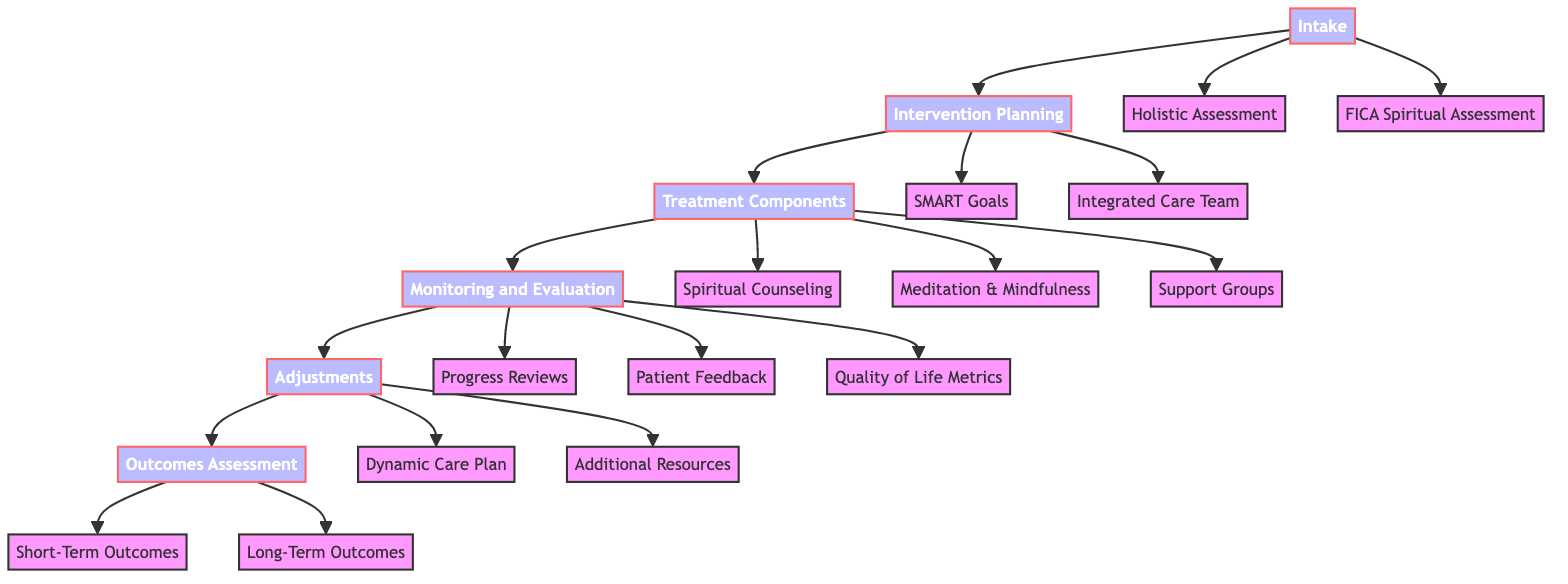What is the first step in the clinical pathway? The first step shown in the diagram is "Intake," indicating that this is the starting point of the clinical pathway.
Answer: Intake How many members are in the integrated care team? The diagram lists four members: Primary Physician, Oncology Specialist, Certified Spiritual Counselor, and Clinical Psychologist. Counting these, we find there are four members in total.
Answer: 4 What type of assessment tool is used for spiritual history? The diagram specifies the "FICA Spiritual Assessment Tool" as the assessment used for spiritual history.
Answer: FICA Spiritual Assessment Tool What is the frequency of spiritual counseling sessions? According to the diagram, spiritual counseling sessions are conducted weekly, as indicated in the "treatment components" section.
Answer: Weekly How often are progress reviews conducted by the healthcare team? The diagram states that progress reviews are done bi-monthly, which means every two months.
Answer: Bi-monthly What is the primary focus of the spiritual counseling sessions? The focus of the spiritual counseling sessions is on addressing "spiritual distress and existential questions," which is explicitly mentioned in the treatment components section.
Answer: Spiritual distress and existential questions What will lead to the adjustment of care plans? The diagram indicates that care plans are adjusted based on "patient response and spiritual needs," linking the evaluation of patient status to care plan modifications.
Answer: Patient response and spiritual needs What kind of feedback is collected from patients? The diagram shows that patient feedback is obtained through "qualitative feedback via interviews and surveys," indicating the methods used for gathering input from patients.
Answer: Qualitative feedback via interviews and surveys What are the short-term outcomes of this pathway? The diagram presents "Reduction in Symptoms of Spiritual Distress" as the short-term outcome, directly indicating what is expected shortly after intervention.
Answer: Reduction in Symptoms of Spiritual Distress 